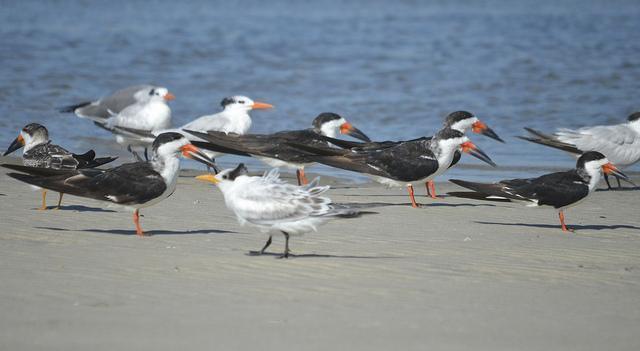What part does this animal have that is absent in humans?
Pick the correct solution from the four options below to address the question.
Options: Exoskeleton, wings, quills, stinger. Wings. 